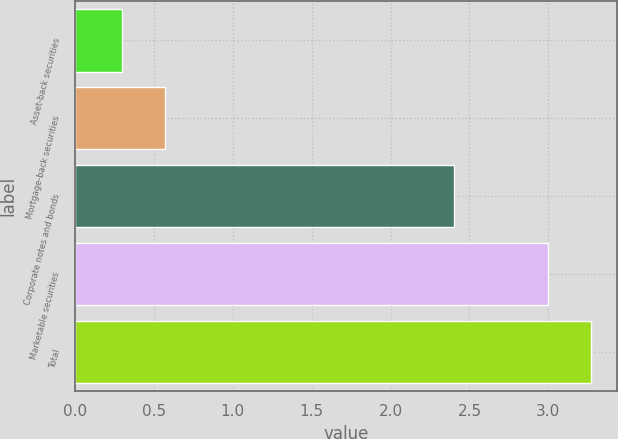Convert chart to OTSL. <chart><loc_0><loc_0><loc_500><loc_500><bar_chart><fcel>Asset-back securities<fcel>Mortgage-back securities<fcel>Corporate notes and bonds<fcel>Marketable securities<fcel>Total<nl><fcel>0.3<fcel>0.57<fcel>2.4<fcel>3<fcel>3.27<nl></chart> 